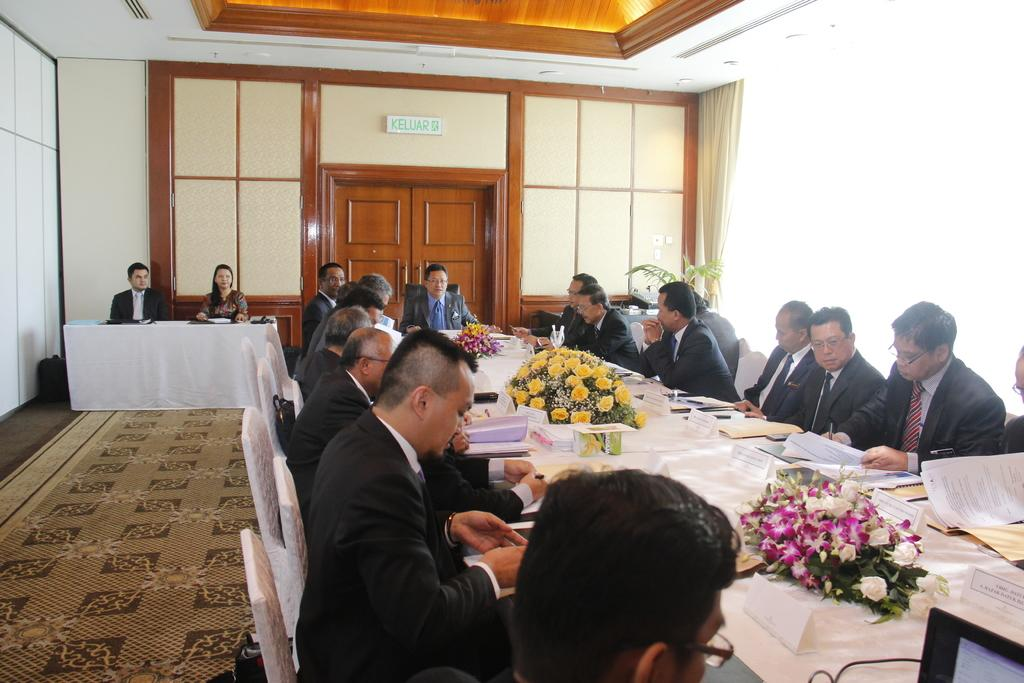What is the color of the wall in the image? The wall in the image is white. What can be found on the wall in the image? There is a door on the wall in the image. What are the people in the image doing? The people in the image are sitting on chairs. What is on the table in the image? There are papers, books, and bouquets on the table in the image. How many feet are visible in the image? There is no mention of feet in the image, so it is impossible to determine how many are visible. 